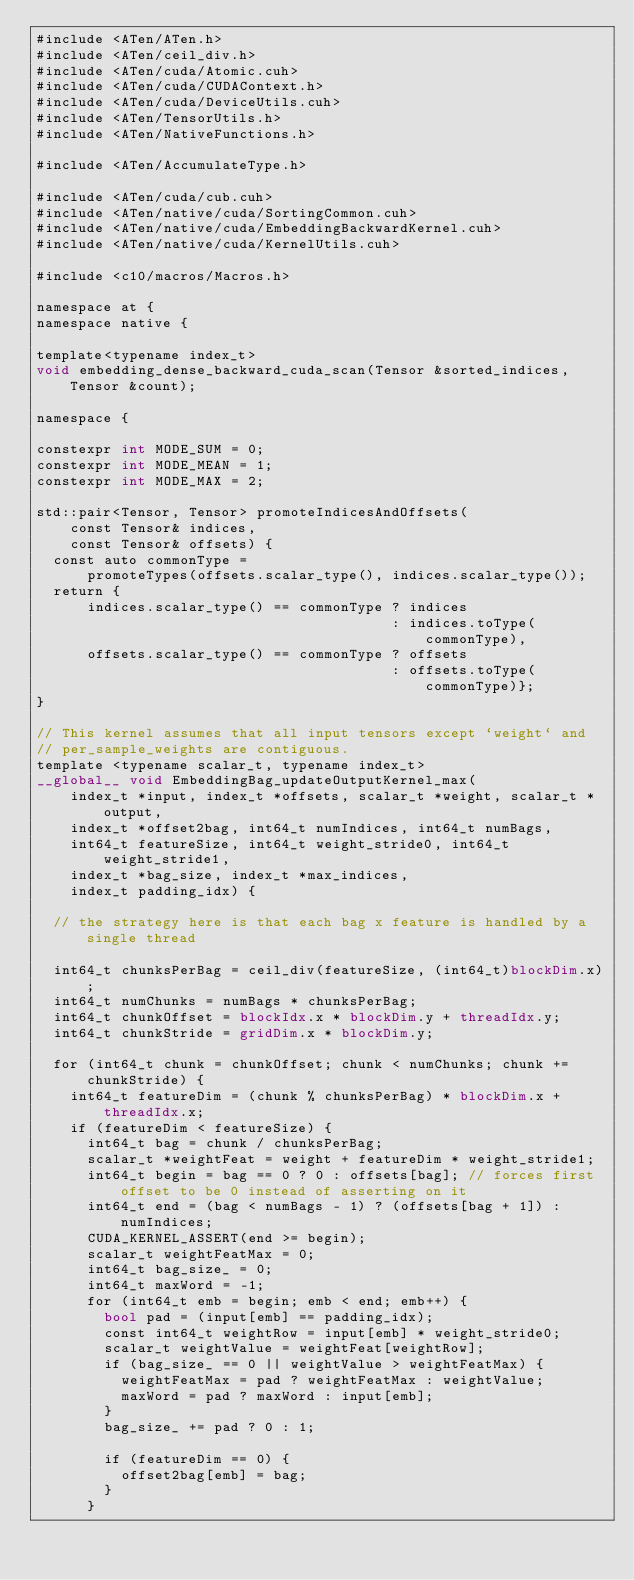Convert code to text. <code><loc_0><loc_0><loc_500><loc_500><_Cuda_>#include <ATen/ATen.h>
#include <ATen/ceil_div.h>
#include <ATen/cuda/Atomic.cuh>
#include <ATen/cuda/CUDAContext.h>
#include <ATen/cuda/DeviceUtils.cuh>
#include <ATen/TensorUtils.h>
#include <ATen/NativeFunctions.h>

#include <ATen/AccumulateType.h>

#include <ATen/cuda/cub.cuh>
#include <ATen/native/cuda/SortingCommon.cuh>
#include <ATen/native/cuda/EmbeddingBackwardKernel.cuh>
#include <ATen/native/cuda/KernelUtils.cuh>

#include <c10/macros/Macros.h>

namespace at {
namespace native {

template<typename index_t>
void embedding_dense_backward_cuda_scan(Tensor &sorted_indices, Tensor &count);

namespace {

constexpr int MODE_SUM = 0;
constexpr int MODE_MEAN = 1;
constexpr int MODE_MAX = 2;

std::pair<Tensor, Tensor> promoteIndicesAndOffsets(
    const Tensor& indices,
    const Tensor& offsets) {
  const auto commonType =
      promoteTypes(offsets.scalar_type(), indices.scalar_type());
  return {
      indices.scalar_type() == commonType ? indices
                                          : indices.toType(commonType),
      offsets.scalar_type() == commonType ? offsets
                                          : offsets.toType(commonType)};
}

// This kernel assumes that all input tensors except `weight` and
// per_sample_weights are contiguous.
template <typename scalar_t, typename index_t>
__global__ void EmbeddingBag_updateOutputKernel_max(
    index_t *input, index_t *offsets, scalar_t *weight, scalar_t *output,
    index_t *offset2bag, int64_t numIndices, int64_t numBags,
    int64_t featureSize, int64_t weight_stride0, int64_t weight_stride1,
    index_t *bag_size, index_t *max_indices,
    index_t padding_idx) {

  // the strategy here is that each bag x feature is handled by a single thread

  int64_t chunksPerBag = ceil_div(featureSize, (int64_t)blockDim.x);
  int64_t numChunks = numBags * chunksPerBag;
  int64_t chunkOffset = blockIdx.x * blockDim.y + threadIdx.y;
  int64_t chunkStride = gridDim.x * blockDim.y;

  for (int64_t chunk = chunkOffset; chunk < numChunks; chunk += chunkStride) {
    int64_t featureDim = (chunk % chunksPerBag) * blockDim.x + threadIdx.x;
    if (featureDim < featureSize) {
      int64_t bag = chunk / chunksPerBag;
      scalar_t *weightFeat = weight + featureDim * weight_stride1;
      int64_t begin = bag == 0 ? 0 : offsets[bag]; // forces first offset to be 0 instead of asserting on it
      int64_t end = (bag < numBags - 1) ? (offsets[bag + 1]) : numIndices;
      CUDA_KERNEL_ASSERT(end >= begin);
      scalar_t weightFeatMax = 0;
      int64_t bag_size_ = 0;
      int64_t maxWord = -1;
      for (int64_t emb = begin; emb < end; emb++) {
        bool pad = (input[emb] == padding_idx);
        const int64_t weightRow = input[emb] * weight_stride0;
        scalar_t weightValue = weightFeat[weightRow];
        if (bag_size_ == 0 || weightValue > weightFeatMax) {
          weightFeatMax = pad ? weightFeatMax : weightValue;
          maxWord = pad ? maxWord : input[emb];
        }
        bag_size_ += pad ? 0 : 1;

        if (featureDim == 0) {
          offset2bag[emb] = bag;
        }
      }</code> 